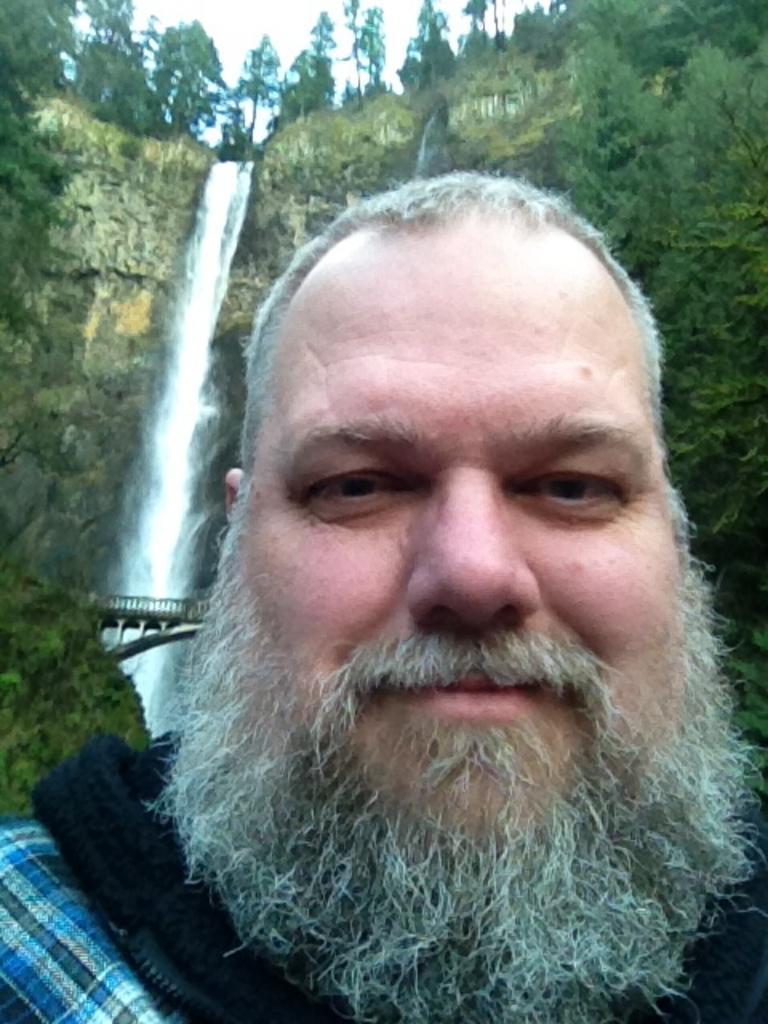How would you summarize this image in a sentence or two? In the picture we can see a man standing and he is with a beard, which is gray in color and behind him we can see hills with some plants to it and waterfall from the top of the hills and on the top of the hill we can see some trees and sky and between the two hills we can see a bridge with railing to it. 